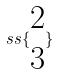<formula> <loc_0><loc_0><loc_500><loc_500>s s \{ \begin{matrix} 2 \\ 3 \end{matrix} \}</formula> 